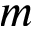<formula> <loc_0><loc_0><loc_500><loc_500>m</formula> 